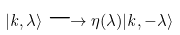Convert formula to latex. <formula><loc_0><loc_0><loc_500><loc_500>| { k } , \lambda \rangle \longrightarrow \eta ( \lambda ) | { k } , - \lambda \rangle</formula> 